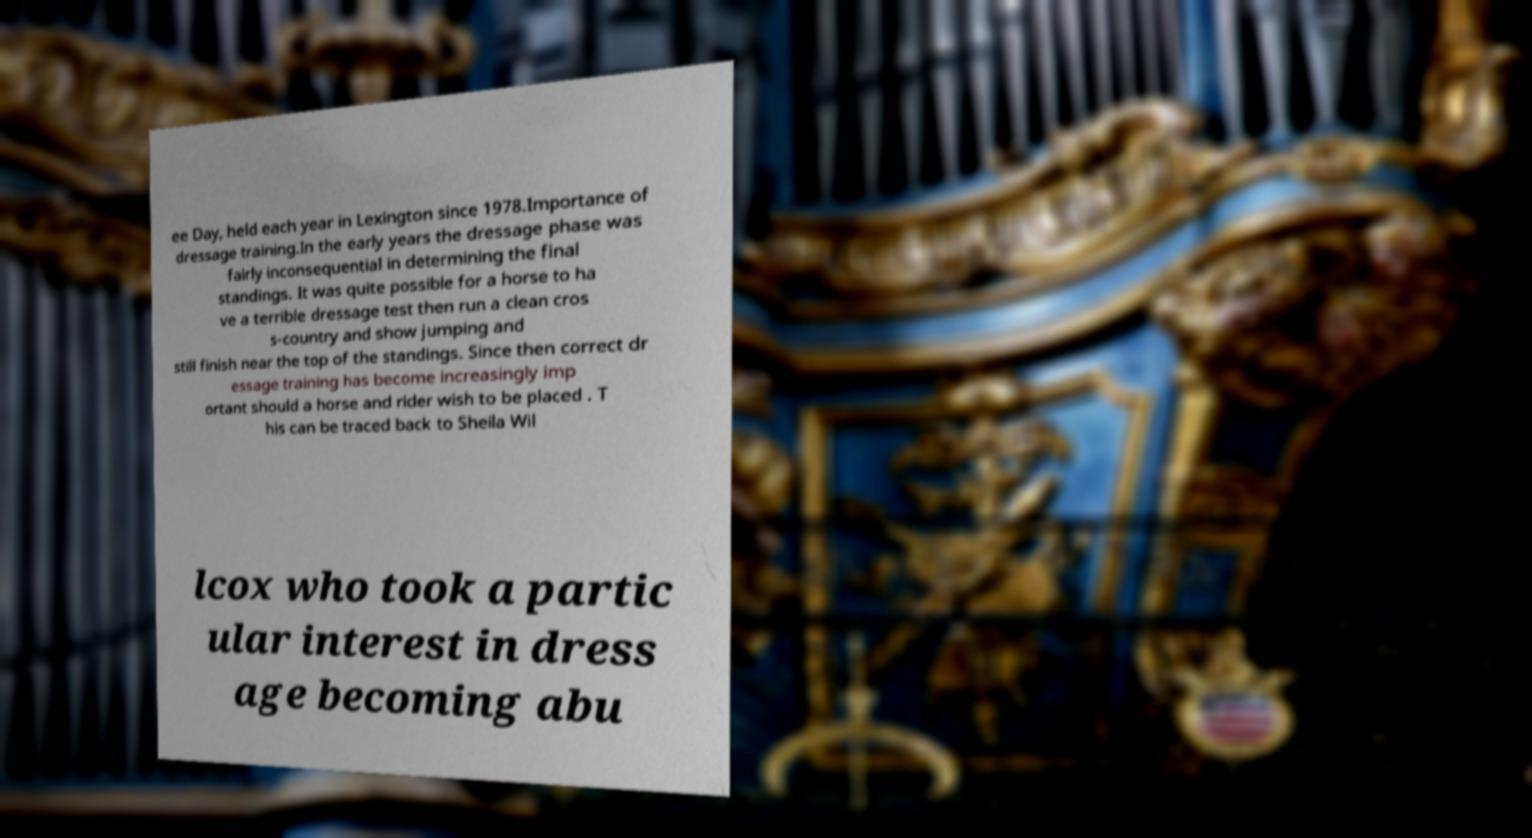Can you read and provide the text displayed in the image?This photo seems to have some interesting text. Can you extract and type it out for me? ee Day, held each year in Lexington since 1978.Importance of dressage training.In the early years the dressage phase was fairly inconsequential in determining the final standings. It was quite possible for a horse to ha ve a terrible dressage test then run a clean cros s-country and show jumping and still finish near the top of the standings. Since then correct dr essage training has become increasingly imp ortant should a horse and rider wish to be placed . T his can be traced back to Sheila Wil lcox who took a partic ular interest in dress age becoming abu 